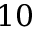Convert formula to latex. <formula><loc_0><loc_0><loc_500><loc_500>1 0</formula> 